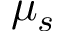Convert formula to latex. <formula><loc_0><loc_0><loc_500><loc_500>\mu _ { s }</formula> 